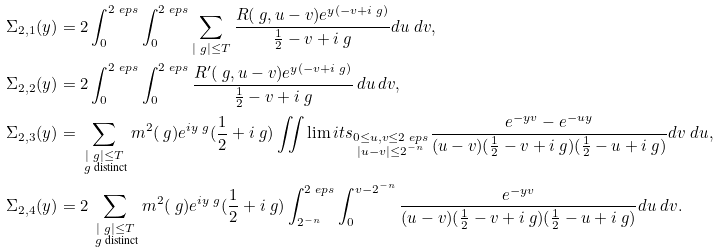Convert formula to latex. <formula><loc_0><loc_0><loc_500><loc_500>\Sigma _ { 2 , 1 } ( y ) & = 2 \int _ { 0 } ^ { 2 \ e p s } \int _ { 0 } ^ { 2 \ e p s } \sum _ { | \ g | \leq T } \frac { R ( \ g , u - v ) e ^ { y ( - v + i \ g ) } } { \frac { 1 } { 2 } - v + i \ g } d u \ d v , \\ \Sigma _ { 2 , 2 } ( y ) & = 2 \int _ { 0 } ^ { 2 \ e p s } \int _ { 0 } ^ { 2 \ e p s } \frac { R ^ { \prime } ( \ g , u - v ) e ^ { y ( - v + i \ g ) } } { \frac { 1 } { 2 } - v + i \ g } \, d u \, d v , \\ \Sigma _ { 2 , 3 } ( y ) & = \sum _ { \substack { | \ g | \leq T \\ \ g \text { distinct} } } m ^ { 2 } ( \ g ) e ^ { i y \ g } ( \frac { 1 } { 2 } + i \ g ) \iint \lim i t s _ { \substack { 0 \leq u , v \leq 2 \ e p s \\ | u - v | \leq 2 ^ { - n } } } \frac { e ^ { - y v } - e ^ { - u y } } { ( u - v ) ( \frac { 1 } { 2 } - v + i \ g ) ( \frac { 1 } { 2 } - u + i \ g ) } d v \ d u , \\ \Sigma _ { 2 , 4 } ( y ) & = 2 \sum _ { \substack { | \ g | \leq T \\ \ g \text { distinct} } } m ^ { 2 } ( \ g ) e ^ { i y \ g } ( \frac { 1 } { 2 } + i \ g ) \int _ { 2 ^ { - n } } ^ { 2 \ e p s } \int _ { 0 } ^ { v - 2 ^ { - n } } \frac { e ^ { - y v } } { ( u - v ) ( \frac { 1 } { 2 } - v + i \ g ) ( \frac { 1 } { 2 } - u + i \ g ) } d u \ d v .</formula> 